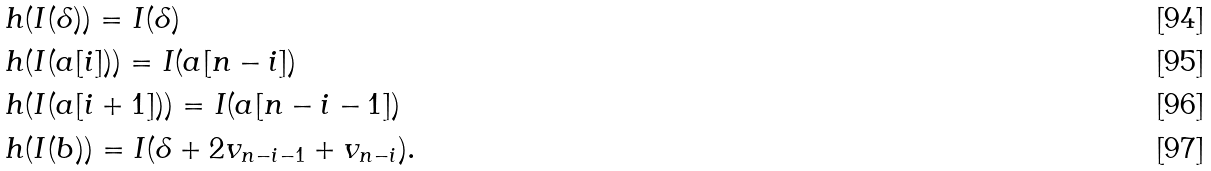Convert formula to latex. <formula><loc_0><loc_0><loc_500><loc_500>& \ h ( I ( \delta ) ) = I ( \delta ) \\ & \ h ( I ( a [ i ] ) ) = I ( a [ n - i ] ) \\ & \ h ( I ( a [ i + 1 ] ) ) = I ( a [ n - i - 1 ] ) \\ & \ h ( I ( b ) ) = I ( \delta + 2 v _ { n - i - 1 } + v _ { n - i } ) .</formula> 